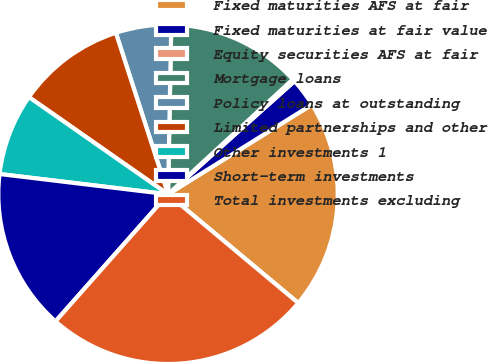<chart> <loc_0><loc_0><loc_500><loc_500><pie_chart><fcel>Fixed maturities AFS at fair<fcel>Fixed maturities at fair value<fcel>Equity securities AFS at fair<fcel>Mortgage loans<fcel>Policy loans at outstanding<fcel>Limited partnerships and other<fcel>Other investments 1<fcel>Short-term investments<fcel>Total investments excluding<nl><fcel>19.94%<fcel>2.75%<fcel>0.23%<fcel>12.85%<fcel>5.28%<fcel>10.32%<fcel>7.8%<fcel>15.37%<fcel>25.46%<nl></chart> 